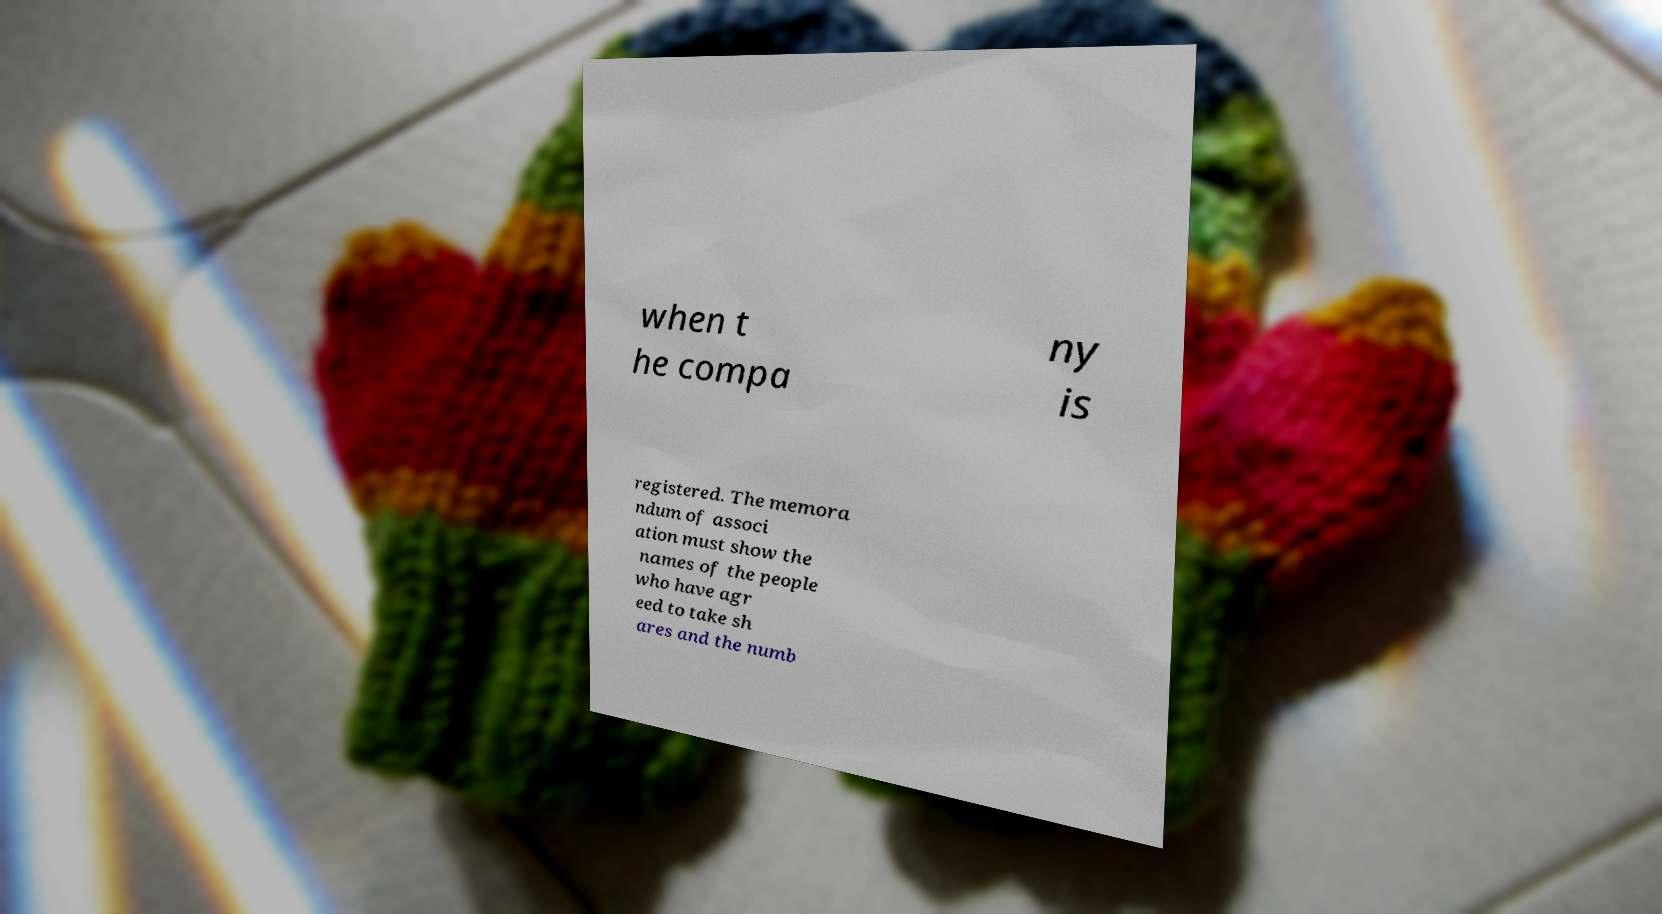Can you read and provide the text displayed in the image?This photo seems to have some interesting text. Can you extract and type it out for me? when t he compa ny is registered. The memora ndum of associ ation must show the names of the people who have agr eed to take sh ares and the numb 